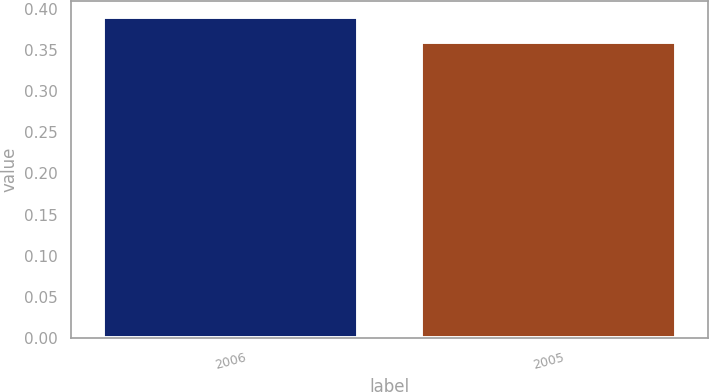Convert chart. <chart><loc_0><loc_0><loc_500><loc_500><bar_chart><fcel>2006<fcel>2005<nl><fcel>0.39<fcel>0.36<nl></chart> 